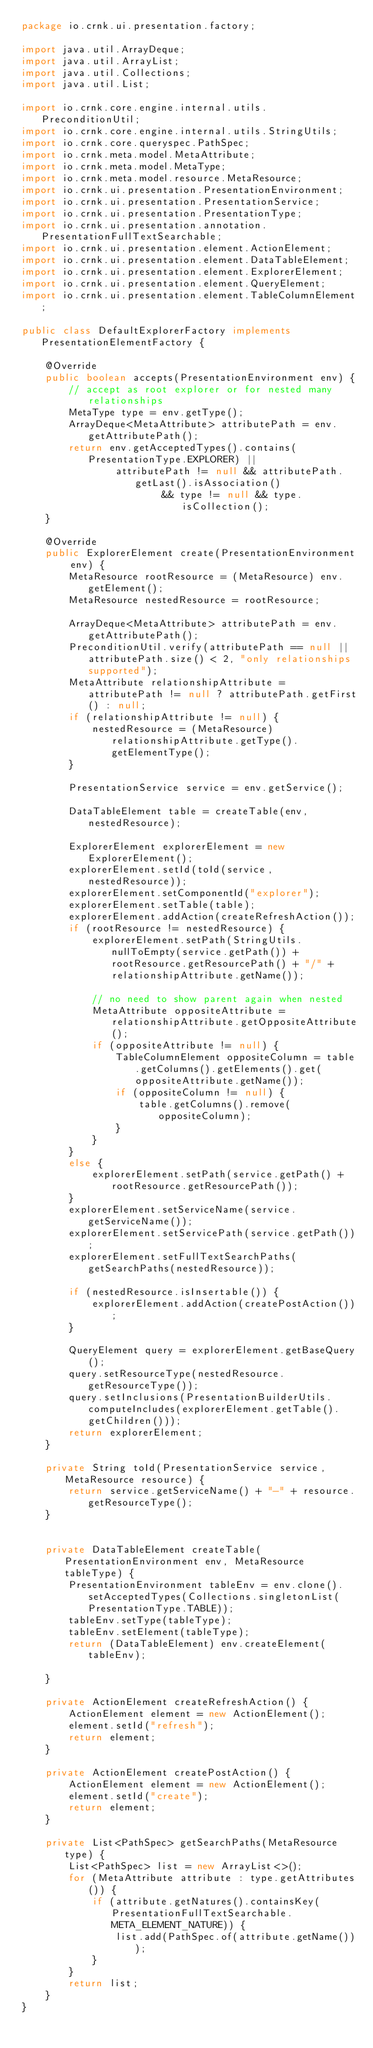Convert code to text. <code><loc_0><loc_0><loc_500><loc_500><_Java_>package io.crnk.ui.presentation.factory;

import java.util.ArrayDeque;
import java.util.ArrayList;
import java.util.Collections;
import java.util.List;

import io.crnk.core.engine.internal.utils.PreconditionUtil;
import io.crnk.core.engine.internal.utils.StringUtils;
import io.crnk.core.queryspec.PathSpec;
import io.crnk.meta.model.MetaAttribute;
import io.crnk.meta.model.MetaType;
import io.crnk.meta.model.resource.MetaResource;
import io.crnk.ui.presentation.PresentationEnvironment;
import io.crnk.ui.presentation.PresentationService;
import io.crnk.ui.presentation.PresentationType;
import io.crnk.ui.presentation.annotation.PresentationFullTextSearchable;
import io.crnk.ui.presentation.element.ActionElement;
import io.crnk.ui.presentation.element.DataTableElement;
import io.crnk.ui.presentation.element.ExplorerElement;
import io.crnk.ui.presentation.element.QueryElement;
import io.crnk.ui.presentation.element.TableColumnElement;

public class DefaultExplorerFactory implements PresentationElementFactory {

	@Override
	public boolean accepts(PresentationEnvironment env) {
		// accept as root explorer or for nested many relationships
		MetaType type = env.getType();
		ArrayDeque<MetaAttribute> attributePath = env.getAttributePath();
		return env.getAcceptedTypes().contains(PresentationType.EXPLORER) ||
				attributePath != null && attributePath.getLast().isAssociation()
						&& type != null && type.isCollection();
	}

	@Override
	public ExplorerElement create(PresentationEnvironment env) {
		MetaResource rootResource = (MetaResource) env.getElement();
		MetaResource nestedResource = rootResource;

		ArrayDeque<MetaAttribute> attributePath = env.getAttributePath();
		PreconditionUtil.verify(attributePath == null || attributePath.size() < 2, "only relationships supported");
		MetaAttribute relationshipAttribute = attributePath != null ? attributePath.getFirst() : null;
		if (relationshipAttribute != null) {
			nestedResource = (MetaResource) relationshipAttribute.getType().getElementType();
		}

		PresentationService service = env.getService();

		DataTableElement table = createTable(env, nestedResource);

		ExplorerElement explorerElement = new ExplorerElement();
		explorerElement.setId(toId(service, nestedResource));
		explorerElement.setComponentId("explorer");
		explorerElement.setTable(table);
		explorerElement.addAction(createRefreshAction());
		if (rootResource != nestedResource) {
			explorerElement.setPath(StringUtils.nullToEmpty(service.getPath()) + rootResource.getResourcePath() + "/" + relationshipAttribute.getName());

			// no need to show parent again when nested
			MetaAttribute oppositeAttribute = relationshipAttribute.getOppositeAttribute();
			if (oppositeAttribute != null) {
				TableColumnElement oppositeColumn = table.getColumns().getElements().get(oppositeAttribute.getName());
				if (oppositeColumn != null) {
					table.getColumns().remove(oppositeColumn);
				}
			}
		}
		else {
			explorerElement.setPath(service.getPath() + rootResource.getResourcePath());
		}
		explorerElement.setServiceName(service.getServiceName());
		explorerElement.setServicePath(service.getPath());
		explorerElement.setFullTextSearchPaths(getSearchPaths(nestedResource));

		if (nestedResource.isInsertable()) {
			explorerElement.addAction(createPostAction());
		}

		QueryElement query = explorerElement.getBaseQuery();
		query.setResourceType(nestedResource.getResourceType());
		query.setInclusions(PresentationBuilderUtils.computeIncludes(explorerElement.getTable().getChildren()));
		return explorerElement;
	}

	private String toId(PresentationService service, MetaResource resource) {
		return service.getServiceName() + "-" + resource.getResourceType();
	}


	private DataTableElement createTable(PresentationEnvironment env, MetaResource tableType) {
		PresentationEnvironment tableEnv = env.clone().setAcceptedTypes(Collections.singletonList(PresentationType.TABLE));
		tableEnv.setType(tableType);
		tableEnv.setElement(tableType);
		return (DataTableElement) env.createElement(tableEnv);

	}

	private ActionElement createRefreshAction() {
		ActionElement element = new ActionElement();
		element.setId("refresh");
		return element;
	}

	private ActionElement createPostAction() {
		ActionElement element = new ActionElement();
		element.setId("create");
		return element;
	}

	private List<PathSpec> getSearchPaths(MetaResource type) {
		List<PathSpec> list = new ArrayList<>();
		for (MetaAttribute attribute : type.getAttributes()) {
			if (attribute.getNatures().containsKey(PresentationFullTextSearchable.META_ELEMENT_NATURE)) {
				list.add(PathSpec.of(attribute.getName()));
			}
		}
		return list;
	}
}
</code> 